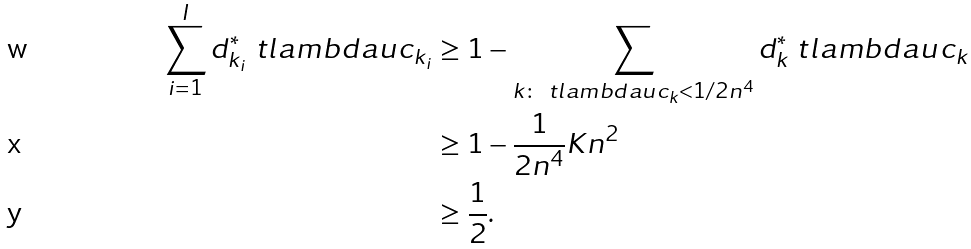Convert formula to latex. <formula><loc_0><loc_0><loc_500><loc_500>\sum _ { i = 1 } ^ { I } d ^ { * } _ { k _ { i } } \ t l a m b d a u c _ { k _ { i } } & \geq 1 - \sum _ { k \colon \ t l a m b d a u c _ { k } < 1 / 2 n ^ { 4 } } d ^ { * } _ { k } \ t l a m b d a u c _ { k } \\ & \geq 1 - \frac { 1 } { 2 n ^ { 4 } } K n ^ { 2 } \\ & \geq \frac { 1 } { 2 } .</formula> 